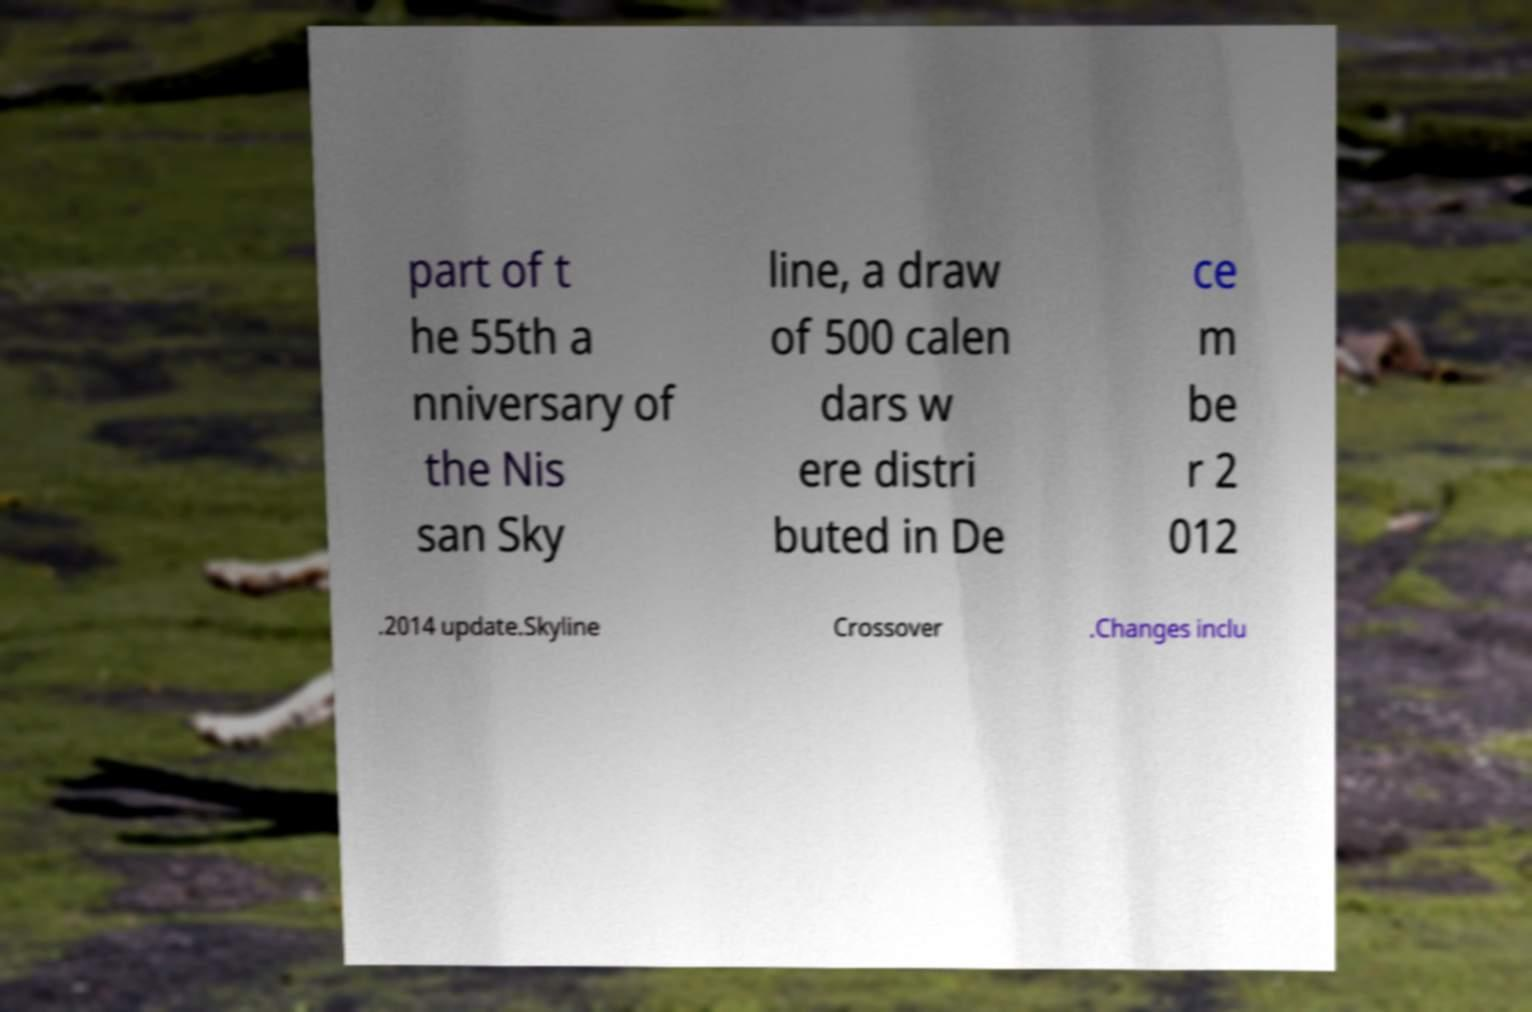Can you accurately transcribe the text from the provided image for me? part of t he 55th a nniversary of the Nis san Sky line, a draw of 500 calen dars w ere distri buted in De ce m be r 2 012 .2014 update.Skyline Crossover .Changes inclu 